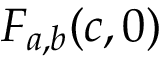Convert formula to latex. <formula><loc_0><loc_0><loc_500><loc_500>F _ { a , b } ( c , 0 )</formula> 